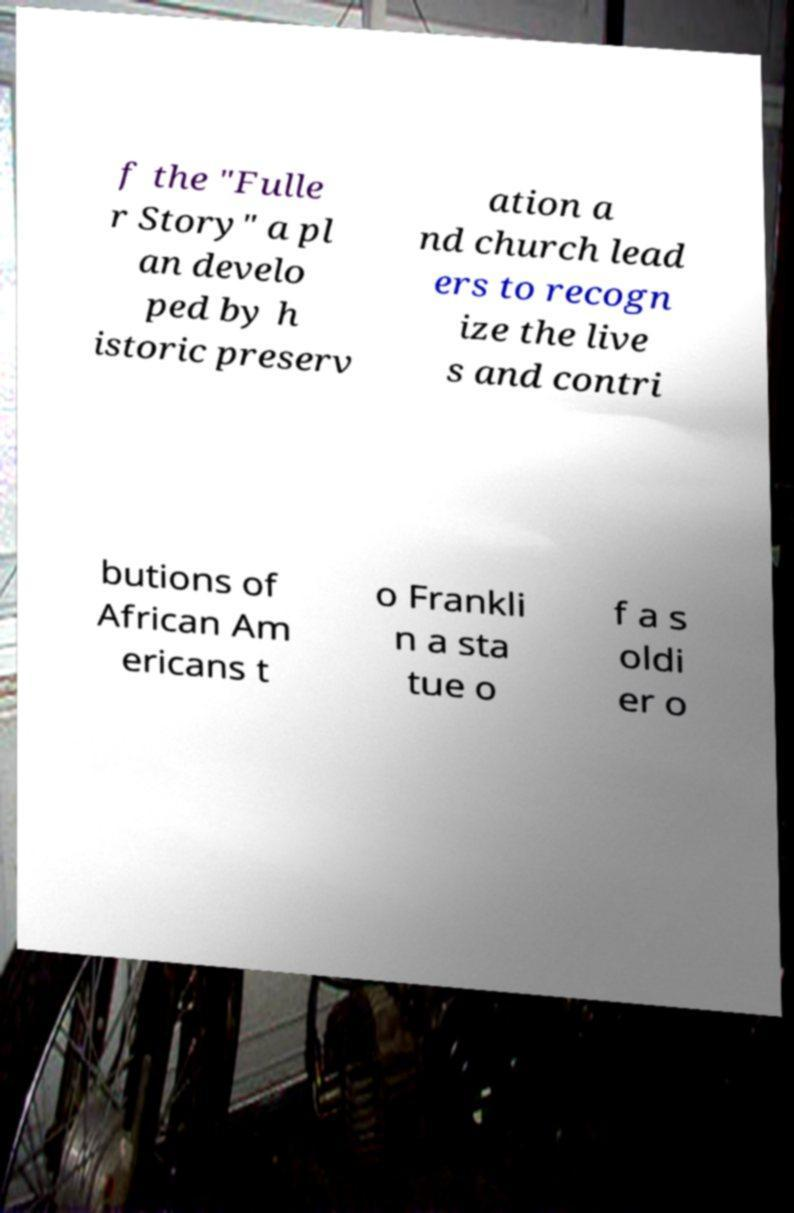Could you extract and type out the text from this image? f the "Fulle r Story" a pl an develo ped by h istoric preserv ation a nd church lead ers to recogn ize the live s and contri butions of African Am ericans t o Frankli n a sta tue o f a s oldi er o 